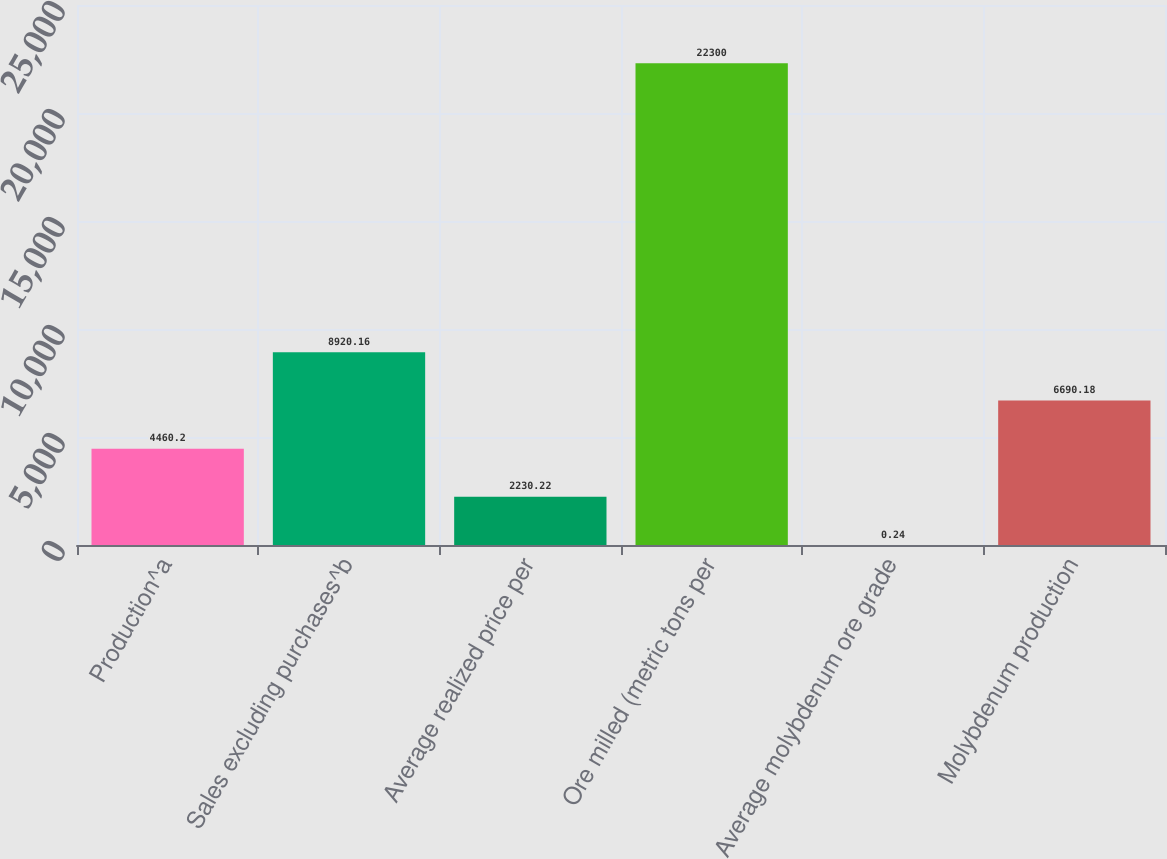Convert chart to OTSL. <chart><loc_0><loc_0><loc_500><loc_500><bar_chart><fcel>Production^a<fcel>Sales excluding purchases^b<fcel>Average realized price per<fcel>Ore milled (metric tons per<fcel>Average molybdenum ore grade<fcel>Molybdenum production<nl><fcel>4460.2<fcel>8920.16<fcel>2230.22<fcel>22300<fcel>0.24<fcel>6690.18<nl></chart> 